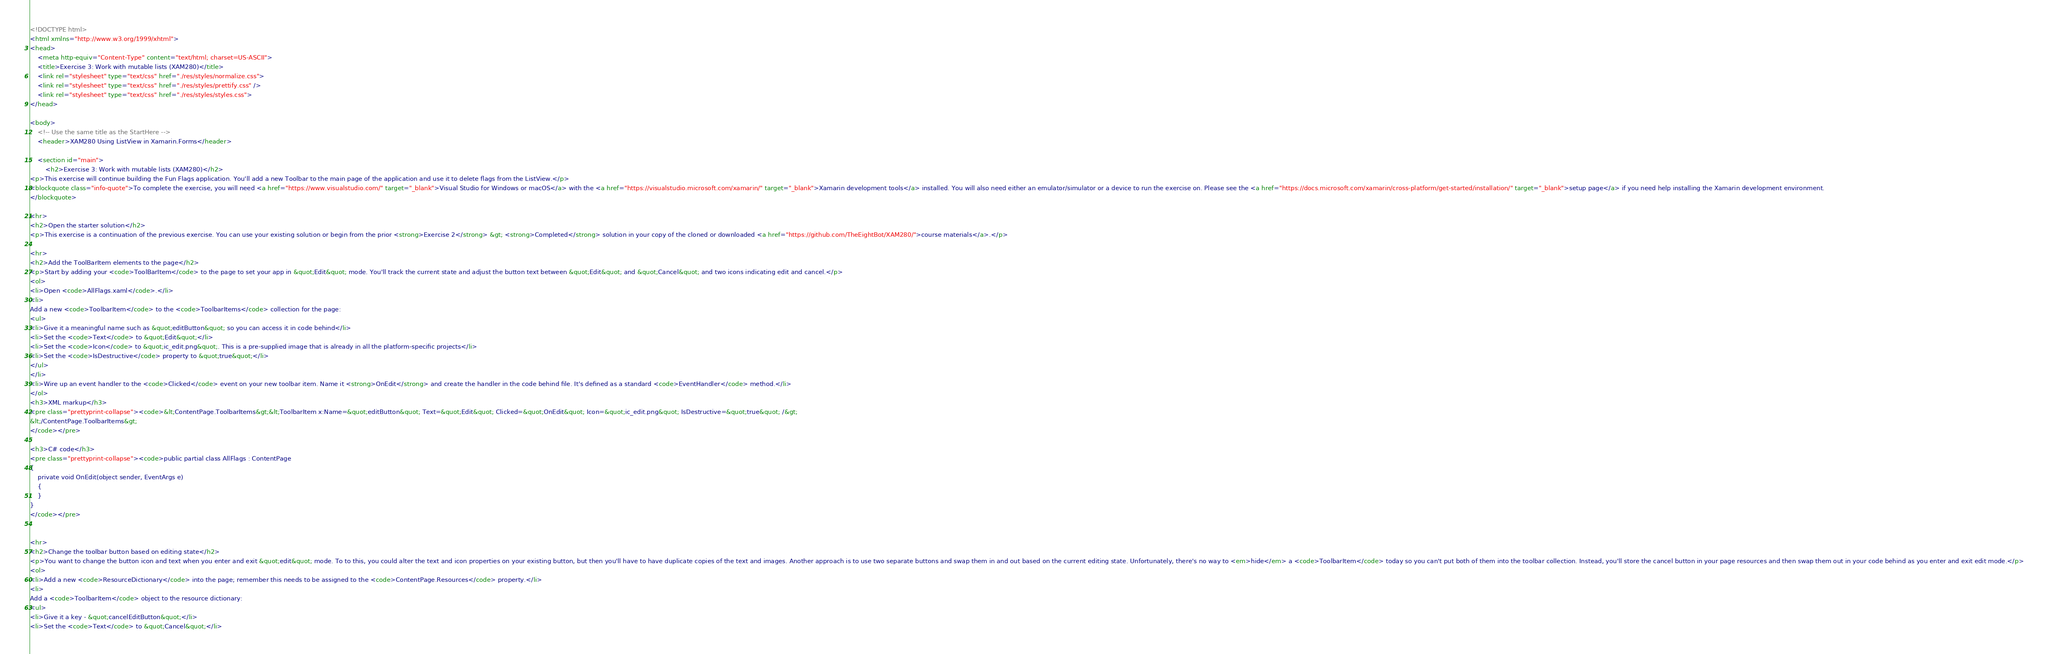Convert code to text. <code><loc_0><loc_0><loc_500><loc_500><_HTML_><!DOCTYPE html>
<html xmlns="http://www.w3.org/1999/xhtml">
<head>
    <meta http-equiv="Content-Type" content="text/html; charset=US-ASCII">
    <title>Exercise 3: Work with mutable lists (XAM280)</title>
    <link rel="stylesheet" type="text/css" href="./res/styles/normalize.css">
    <link rel="stylesheet" type="text/css" href="./res/styles/prettify.css" />
    <link rel="stylesheet" type="text/css" href="./res/styles/styles.css">
</head>

<body>
    <!-- Use the same title as the StartHere -->
    <header>XAM280 Using ListView in Xamarin.Forms</header>

    <section id="main">
        <h2>Exercise 3: Work with mutable lists (XAM280)</h2>
<p>This exercise will continue building the Fun Flags application. You'll add a new Toolbar to the main page of the application and use it to delete flags from the ListView.</p>
<blockquote class="info-quote">To complete the exercise, you will need <a href="https://www.visualstudio.com/" target="_blank">Visual Studio for Windows or macOS</a> with the <a href="https://visualstudio.microsoft.com/xamarin/" target="_blank">Xamarin development tools</a> installed. You will also need either an emulator/simulator or a device to run the exercise on. Please see the <a href="https://docs.microsoft.com/xamarin/cross-platform/get-started/installation/" target="_blank">setup page</a> if you need help installing the Xamarin development environment.
</blockquote>

<hr>
<h2>Open the starter solution</h2>
<p>This exercise is a continuation of the previous exercise. You can use your existing solution or begin from the prior <strong>Exercise 2</strong> &gt; <strong>Completed</strong> solution in your copy of the cloned or downloaded <a href="https://github.com/TheEightBot/XAM280/">course materials</a>.</p>

<hr>
<h2>Add the ToolBarItem elements to the page</h2>
<p>Start by adding your <code>ToolBarItem</code> to the page to set your app in &quot;Edit&quot; mode. You'll track the current state and adjust the button text between &quot;Edit&quot; and &quot;Cancel&quot; and two icons indicating edit and cancel.</p>
<ol>
<li>Open <code>AllFlags.xaml</code>.</li>
<li>
Add a new <code>ToolbarItem</code> to the <code>ToolbarItems</code> collection for the page:
<ul>
<li>Give it a meaningful name such as &quot;editButton&quot; so you can access it in code behind</li>
<li>Set the <code>Text</code> to &quot;Edit&quot;</li>
<li>Set the <code>Icon</code> to &quot;ic_edit.png&quot;. This is a pre-supplied image that is already in all the platform-specific projects</li>
<li>Set the <code>IsDestructive</code> property to &quot;true&quot;</li>
</ul>
</li>
<li>Wire up an event handler to the <code>Clicked</code> event on your new toolbar item. Name it <strong>OnEdit</strong> and create the handler in the code behind file. It's defined as a standard <code>EventHandler</code> method.</li>
</ol>
<h3>XML markup</h3>
<pre class="prettyprint-collapse"><code>&lt;ContentPage.ToolbarItems&gt;&lt;ToolbarItem x:Name=&quot;editButton&quot; Text=&quot;Edit&quot; Clicked=&quot;OnEdit&quot; Icon=&quot;ic_edit.png&quot; IsDestructive=&quot;true&quot; /&gt;
&lt;/ContentPage.ToolbarItems&gt;
</code></pre>

<h3>C# code</h3>
<pre class="prettyprint-collapse"><code>public partial class AllFlags : ContentPage
{
    private void OnEdit(object sender, EventArgs e)
    {
    }
}
</code></pre>


<hr>
<h2>Change the toolbar button based on editing state</h2>
<p>You want to change the button icon and text when you enter and exit &quot;edit&quot; mode. To to this, you could alter the text and icon properties on your existing button, but then you'll have to have duplicate copies of the text and images. Another approach is to use two separate buttons and swap them in and out based on the current editing state. Unfortunately, there's no way to <em>hide</em> a <code>ToolbarItem</code> today so you can't put both of them into the toolbar collection. Instead, you'll store the cancel button in your page resources and then swap them out in your code behind as you enter and exit edit mode.</p>
<ol>
<li>Add a new <code>ResourceDictionary</code> into the page; remember this needs to be assigned to the <code>ContentPage.Resources</code> property.</li>
<li>
Add a <code>ToolbarItem</code> object to the resource dictionary:
<ul>
<li>Give it a key - &quot;cancelEditButton&quot;</li>
<li>Set the <code>Text</code> to &quot;Cancel&quot;</li></code> 